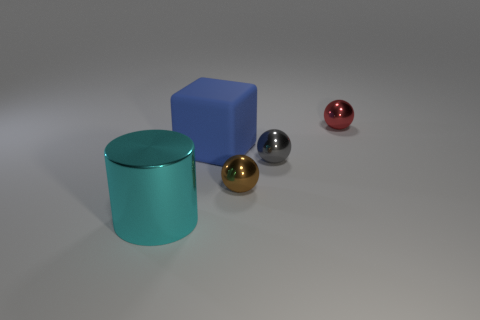Add 4 tiny brown spheres. How many objects exist? 9 Subtract all balls. How many objects are left? 2 Add 2 big metallic cylinders. How many big metallic cylinders exist? 3 Subtract 0 brown cubes. How many objects are left? 5 Subtract all small purple cylinders. Subtract all tiny balls. How many objects are left? 2 Add 2 big cyan shiny objects. How many big cyan shiny objects are left? 3 